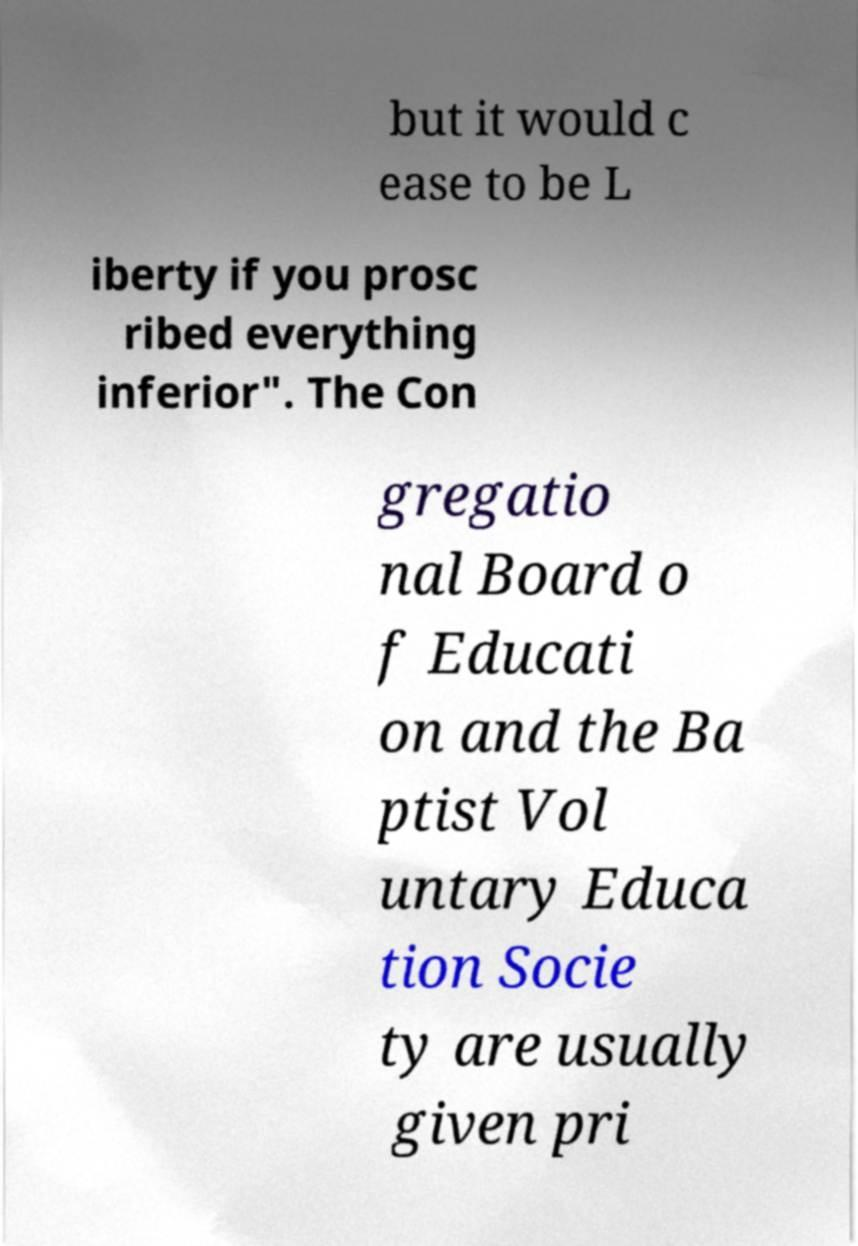Please read and relay the text visible in this image. What does it say? but it would c ease to be L iberty if you prosc ribed everything inferior". The Con gregatio nal Board o f Educati on and the Ba ptist Vol untary Educa tion Socie ty are usually given pri 